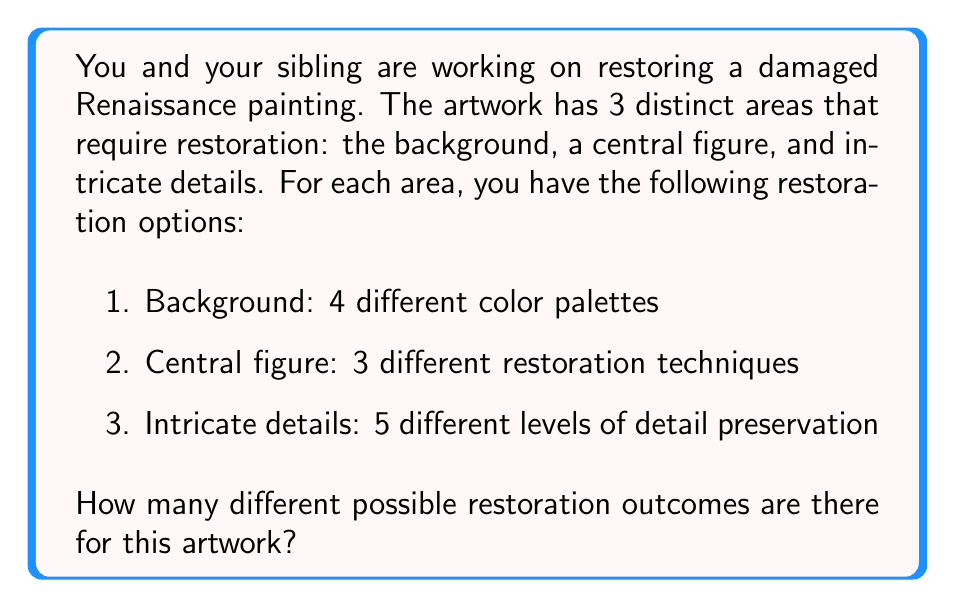Give your solution to this math problem. To solve this problem, we'll use the multiplication principle from combinatorics. The multiplication principle states that if we have a series of independent choices, the total number of possible outcomes is the product of the number of options for each choice.

Let's break down the problem:

1. Background: 4 color palette options
2. Central figure: 3 restoration technique options
3. Intricate details: 5 detail preservation level options

Since each choice is independent (the choice for one area doesn't affect the choices for the other areas), we can multiply the number of options for each area:

$$ \text{Total outcomes} = \text{Background options} \times \text{Central figure options} \times \text{Intricate details options} $$

$$ \text{Total outcomes} = 4 \times 3 \times 5 $$

$$ \text{Total outcomes} = 60 $$

Therefore, there are 60 different possible restoration outcomes for this artwork.
Answer: 60 possible restoration outcomes 